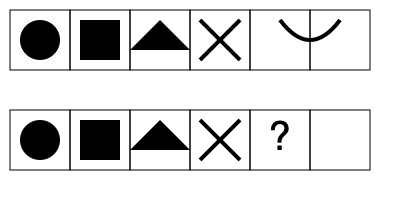In this textile print pattern, what shape should replace the question mark to complete the sequence? To solve this pattern recognition question, we need to analyze the sequence of shapes in both rows:

1. First row (from left to right):
   - Circle
   - Square
   - Triangle
   - X (crossed lines)
   - Curved line

2. Second row (from left to right):
   - Circle
   - Square
   - Triangle
   - X (crossed lines)
   - Question mark (missing shape)

3. We can observe that the second row follows the same pattern as the first row.

4. The missing shape in the second row should correspond to the last shape in the first row.

5. The last shape in the first row is a curved line.

Therefore, the shape that should replace the question mark to complete the sequence is a curved line.
Answer: Curved line 